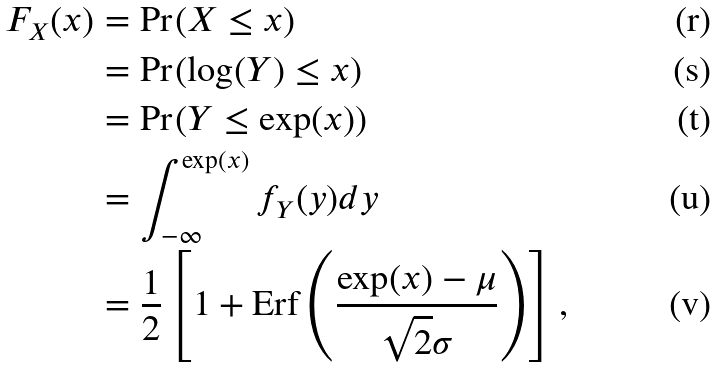Convert formula to latex. <formula><loc_0><loc_0><loc_500><loc_500>F _ { X } ( x ) & = \Pr ( X \leq x ) \\ & = \Pr ( \log ( Y ) \leq x ) \\ & = \Pr ( Y \leq \exp ( x ) ) \\ & = \int _ { - \infty } ^ { \exp ( x ) } f _ { Y } ( y ) d y \\ & = \frac { 1 } { 2 } \left [ 1 + \text {Erf} \left ( \frac { \exp ( x ) - \mu } { \sqrt { 2 } \sigma } \right ) \right ] ,</formula> 